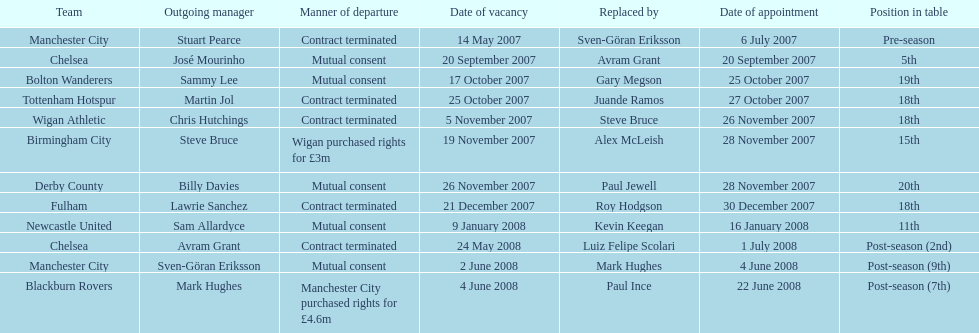How many years, at the very least, was avram grant with chelsea? 1. 